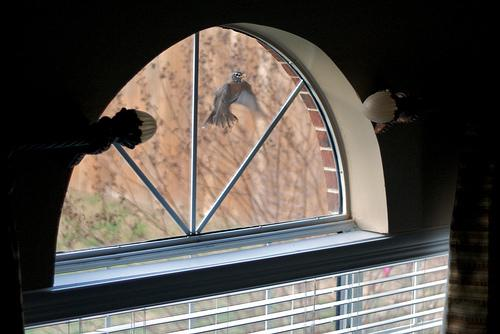Question: who is in the photo?
Choices:
A. Mom.
B. Dad.
C. Sister.
D. No one.
Answer with the letter. Answer: D Question: what animal is that?
Choices:
A. A hen.
B. A dove.
C. A bird.
D. A turkey.
Answer with the letter. Answer: C Question: what is behind the bird?
Choices:
A. A tree.
B. Her nest.
C. Her babies.
D. Her eggs.
Answer with the letter. Answer: A Question: what color is the bird?
Choices:
A. Brown.
B. Black.
C. Gray.
D. Yellow.
Answer with the letter. Answer: A Question: where is the bird?
Choices:
A. In the tree.
B. Outside the window.
C. In the sky.
D. In the clouds.
Answer with the letter. Answer: B Question: what color are the blinds?
Choices:
A. Blue.
B. White.
C. Black.
D. Beige.
Answer with the letter. Answer: B 